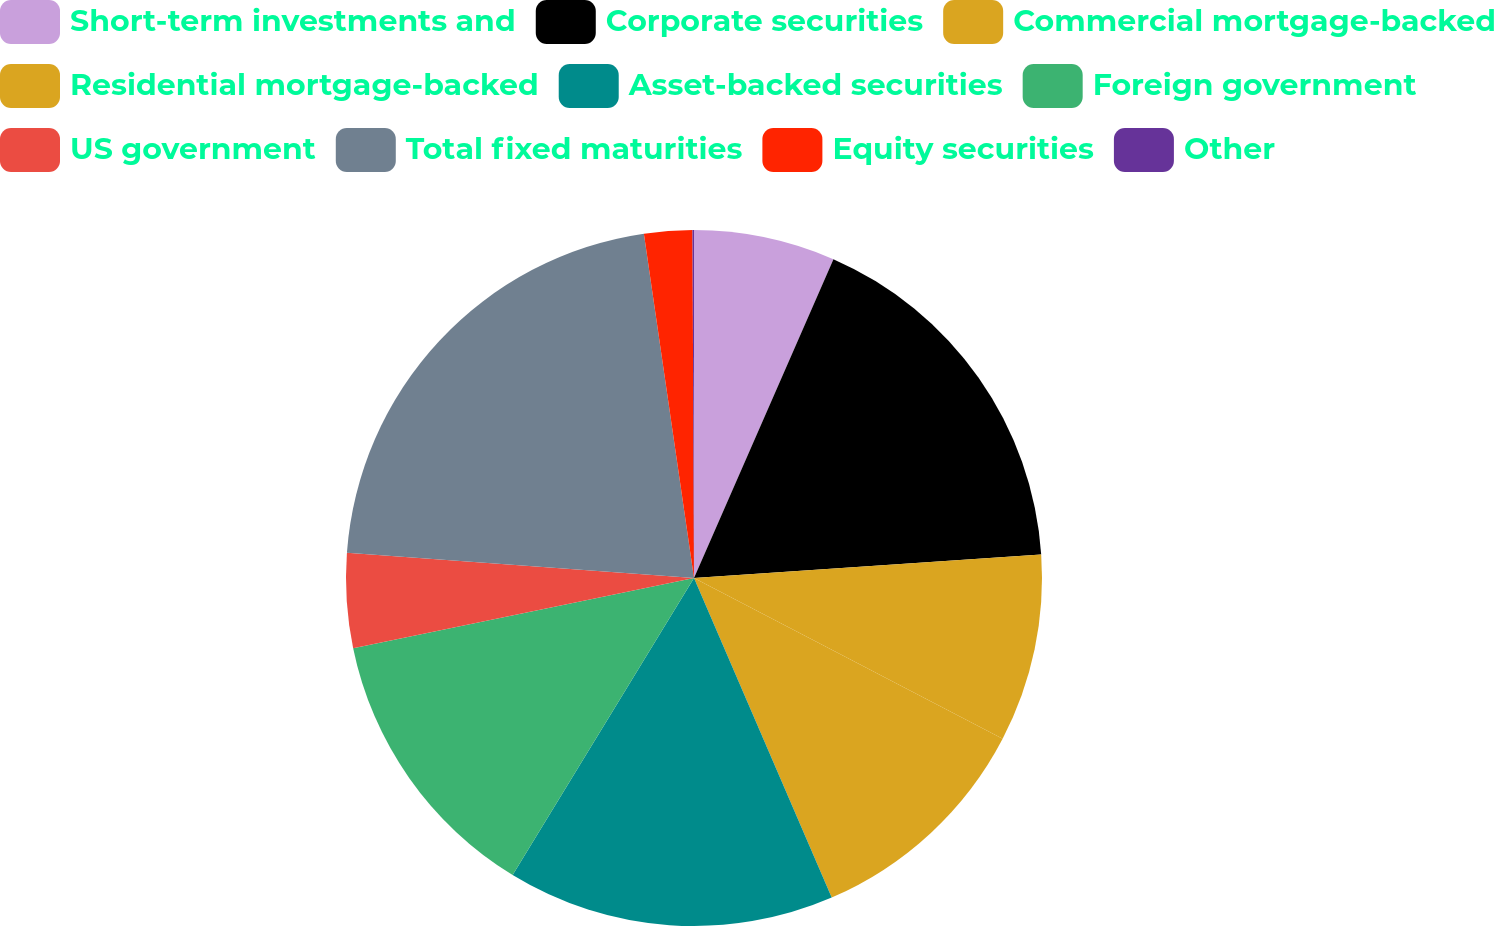Convert chart to OTSL. <chart><loc_0><loc_0><loc_500><loc_500><pie_chart><fcel>Short-term investments and<fcel>Corporate securities<fcel>Commercial mortgage-backed<fcel>Residential mortgage-backed<fcel>Asset-backed securities<fcel>Foreign government<fcel>US government<fcel>Total fixed maturities<fcel>Equity securities<fcel>Other<nl><fcel>6.56%<fcel>17.36%<fcel>8.72%<fcel>10.88%<fcel>15.2%<fcel>13.04%<fcel>4.39%<fcel>21.54%<fcel>2.23%<fcel>0.07%<nl></chart> 